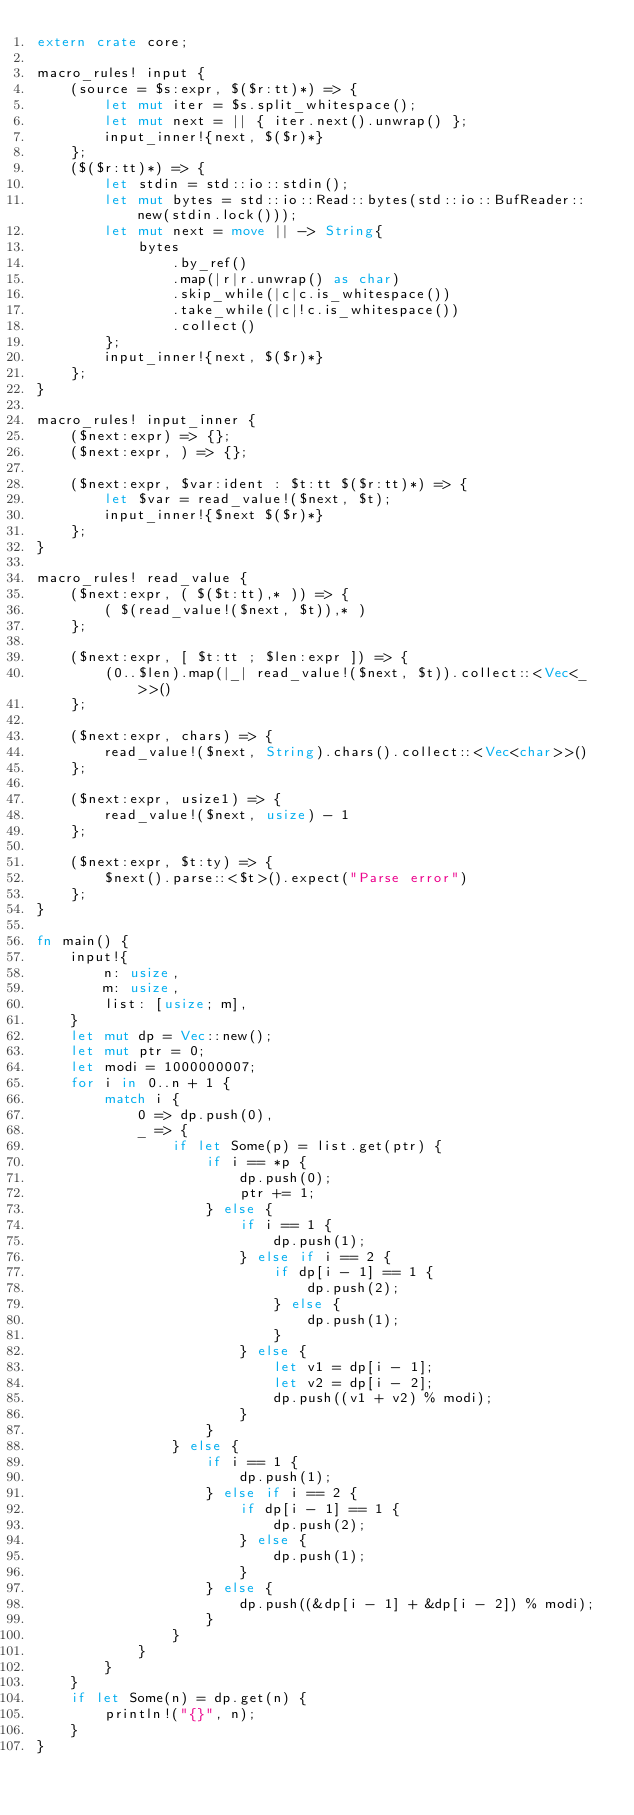Convert code to text. <code><loc_0><loc_0><loc_500><loc_500><_Rust_>extern crate core;

macro_rules! input {
    (source = $s:expr, $($r:tt)*) => {
        let mut iter = $s.split_whitespace();
        let mut next = || { iter.next().unwrap() };
        input_inner!{next, $($r)*}
    };
    ($($r:tt)*) => {
        let stdin = std::io::stdin();
        let mut bytes = std::io::Read::bytes(std::io::BufReader::new(stdin.lock()));
        let mut next = move || -> String{
            bytes
                .by_ref()
                .map(|r|r.unwrap() as char)
                .skip_while(|c|c.is_whitespace())
                .take_while(|c|!c.is_whitespace())
                .collect()
        };
        input_inner!{next, $($r)*}
    };
}

macro_rules! input_inner {
    ($next:expr) => {};
    ($next:expr, ) => {};

    ($next:expr, $var:ident : $t:tt $($r:tt)*) => {
        let $var = read_value!($next, $t);
        input_inner!{$next $($r)*}
    };
}

macro_rules! read_value {
    ($next:expr, ( $($t:tt),* )) => {
        ( $(read_value!($next, $t)),* )
    };

    ($next:expr, [ $t:tt ; $len:expr ]) => {
        (0..$len).map(|_| read_value!($next, $t)).collect::<Vec<_>>()
    };

    ($next:expr, chars) => {
        read_value!($next, String).chars().collect::<Vec<char>>()
    };

    ($next:expr, usize1) => {
        read_value!($next, usize) - 1
    };

    ($next:expr, $t:ty) => {
        $next().parse::<$t>().expect("Parse error")
    };
}

fn main() {
    input!{
        n: usize,
        m: usize,
        list: [usize; m],
    }
    let mut dp = Vec::new();
    let mut ptr = 0;
    let modi = 1000000007;
    for i in 0..n + 1 {
        match i {
            0 => dp.push(0),
            _ => {
                if let Some(p) = list.get(ptr) {
                    if i == *p {
                        dp.push(0);
                        ptr += 1;
                    } else {
                        if i == 1 {
                            dp.push(1);
                        } else if i == 2 {
                            if dp[i - 1] == 1 {
                                dp.push(2);
                            } else {
                                dp.push(1);
                            }
                        } else {
                            let v1 = dp[i - 1];
                            let v2 = dp[i - 2];
                            dp.push((v1 + v2) % modi);
                        }      
                    }
                } else {
                    if i == 1 {
                        dp.push(1);
                    } else if i == 2 {
                        if dp[i - 1] == 1 {
                            dp.push(2);
                        } else {
                            dp.push(1);
                        }
                    } else {
                        dp.push((&dp[i - 1] + &dp[i - 2]) % modi);
                    }
                }
            }
        }
    }
    if let Some(n) = dp.get(n) {
        println!("{}", n);
    }
}</code> 